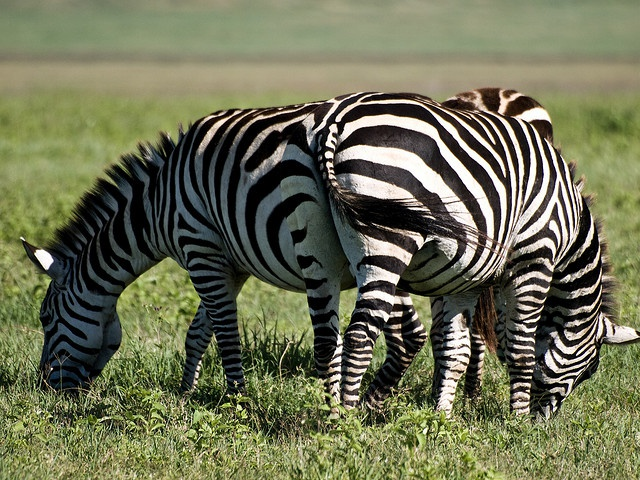Describe the objects in this image and their specific colors. I can see zebra in gray, black, white, and olive tones, zebra in gray, black, purple, and olive tones, and zebra in gray, black, ivory, olive, and tan tones in this image. 